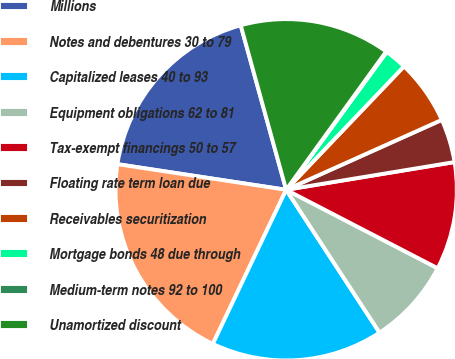Convert chart to OTSL. <chart><loc_0><loc_0><loc_500><loc_500><pie_chart><fcel>Millions<fcel>Notes and debentures 30 to 79<fcel>Capitalized leases 40 to 93<fcel>Equipment obligations 62 to 81<fcel>Tax-exempt financings 50 to 57<fcel>Floating rate term loan due<fcel>Receivables securitization<fcel>Mortgage bonds 48 due through<fcel>Medium-term notes 92 to 100<fcel>Unamortized discount<nl><fcel>18.31%<fcel>20.33%<fcel>16.28%<fcel>8.18%<fcel>10.2%<fcel>4.12%<fcel>6.15%<fcel>2.1%<fcel>0.07%<fcel>14.25%<nl></chart> 